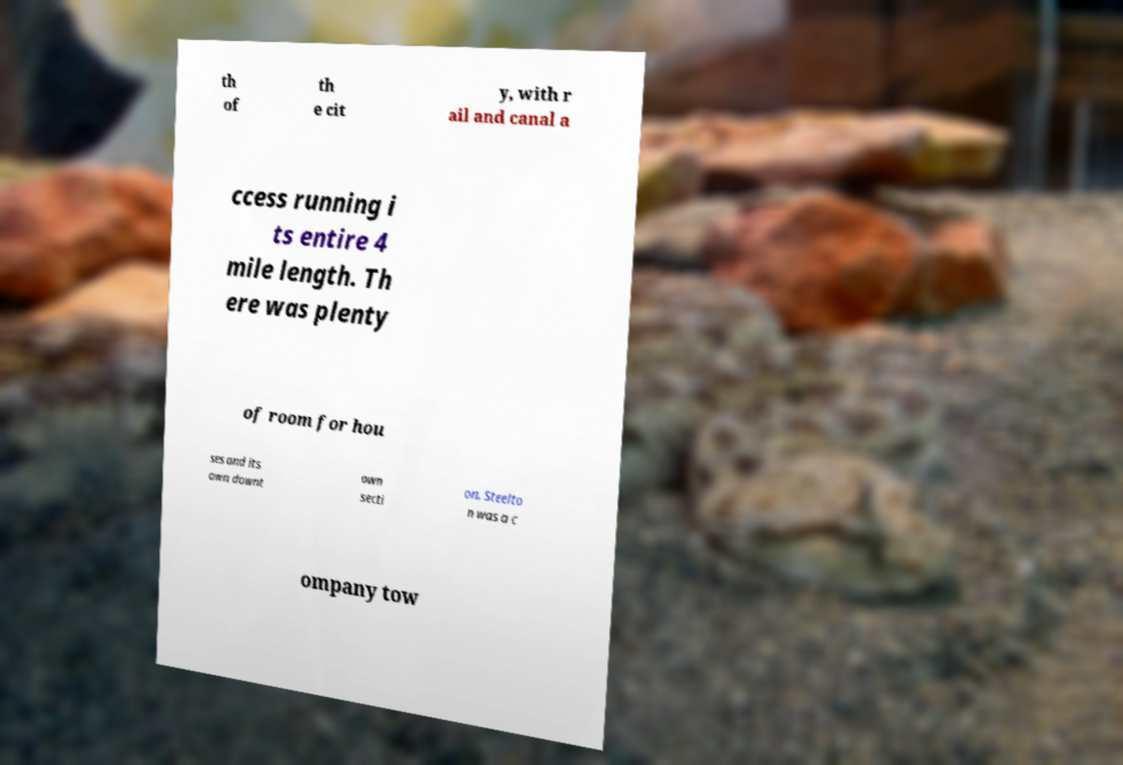Could you extract and type out the text from this image? th of th e cit y, with r ail and canal a ccess running i ts entire 4 mile length. Th ere was plenty of room for hou ses and its own downt own secti on. Steelto n was a c ompany tow 